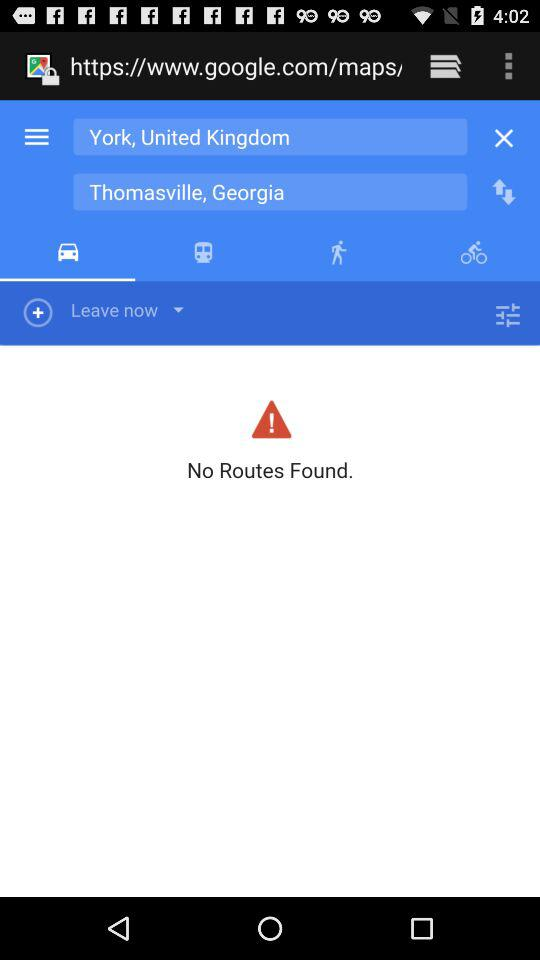What is the destination location? The destination location is "Thomasville, Georgia". 